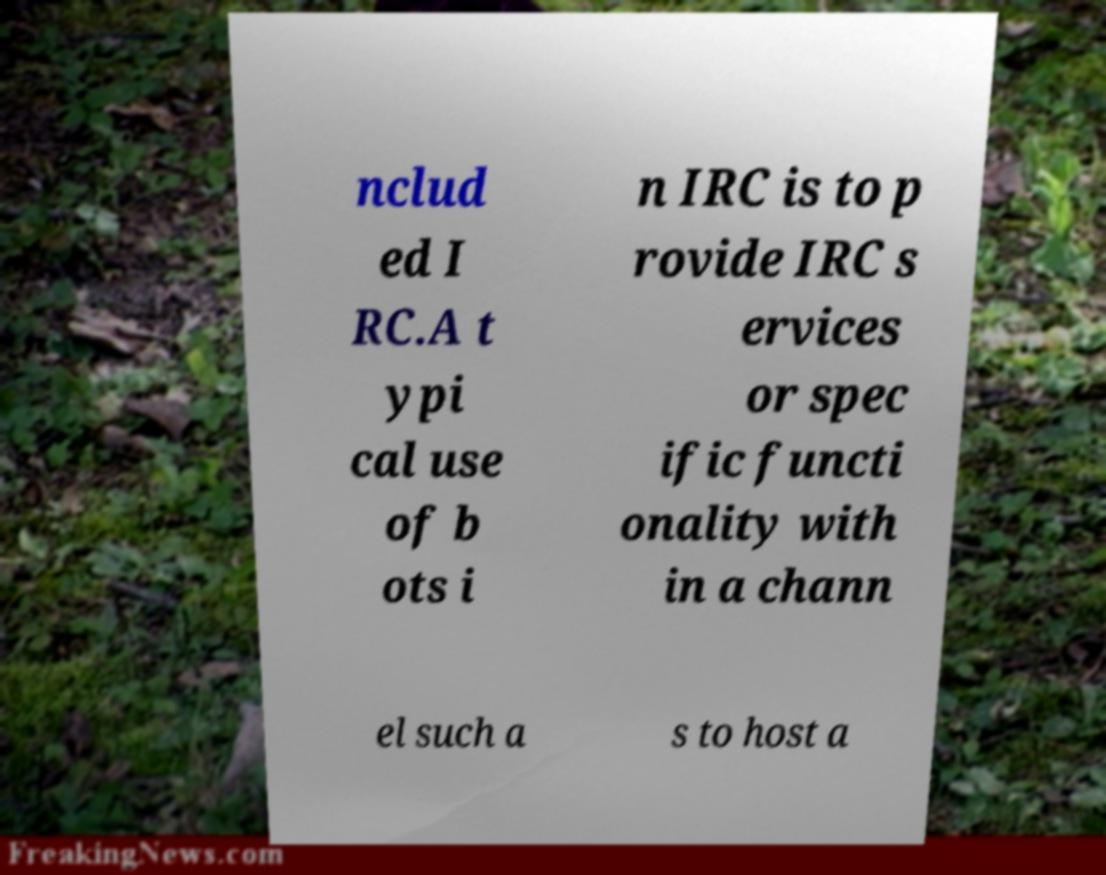Can you read and provide the text displayed in the image?This photo seems to have some interesting text. Can you extract and type it out for me? nclud ed I RC.A t ypi cal use of b ots i n IRC is to p rovide IRC s ervices or spec ific functi onality with in a chann el such a s to host a 